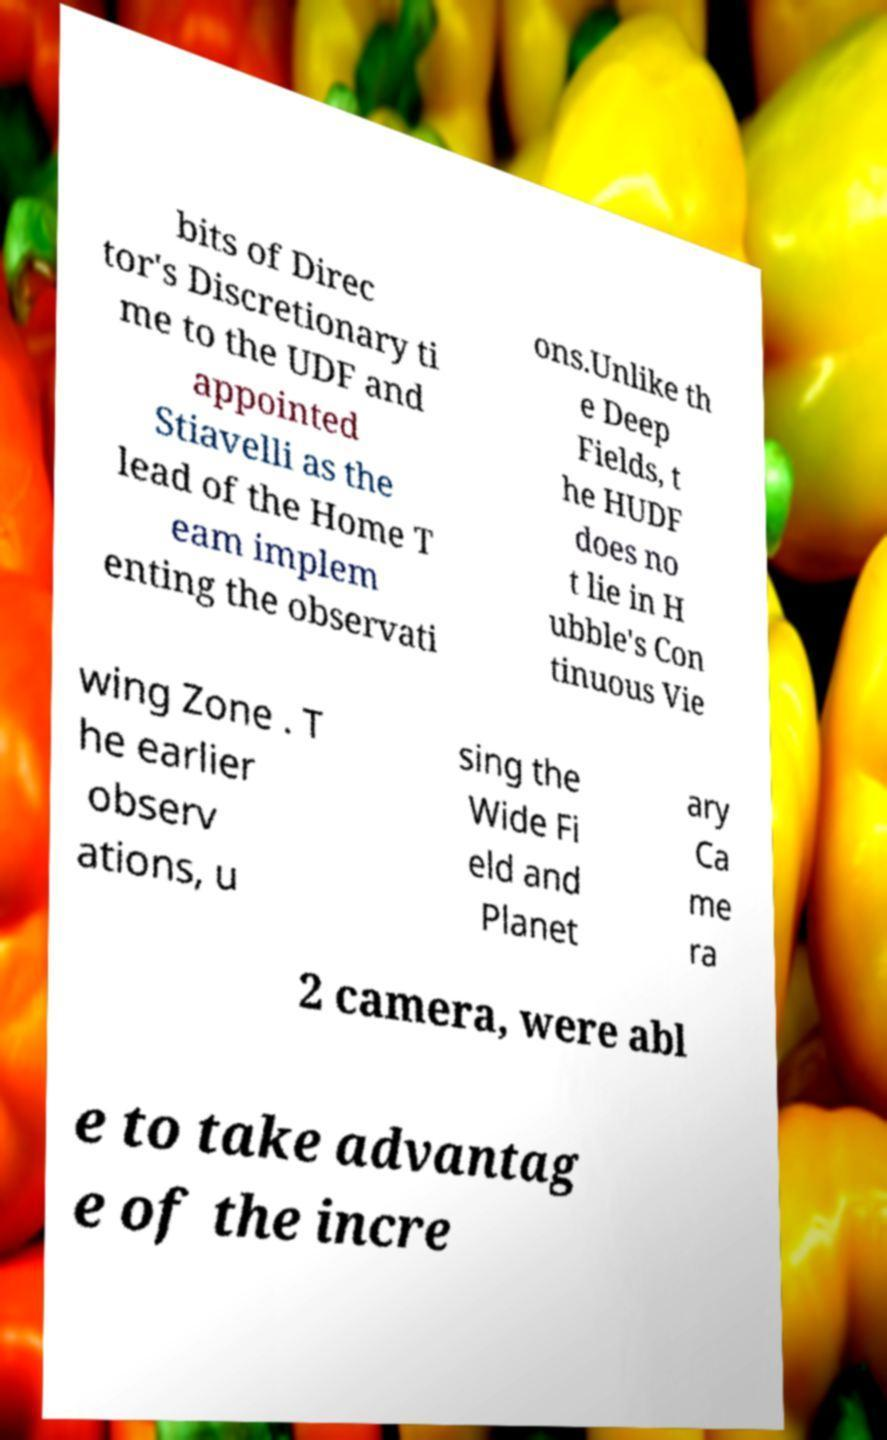What messages or text are displayed in this image? I need them in a readable, typed format. bits of Direc tor's Discretionary ti me to the UDF and appointed Stiavelli as the lead of the Home T eam implem enting the observati ons.Unlike th e Deep Fields, t he HUDF does no t lie in H ubble's Con tinuous Vie wing Zone . T he earlier observ ations, u sing the Wide Fi eld and Planet ary Ca me ra 2 camera, were abl e to take advantag e of the incre 